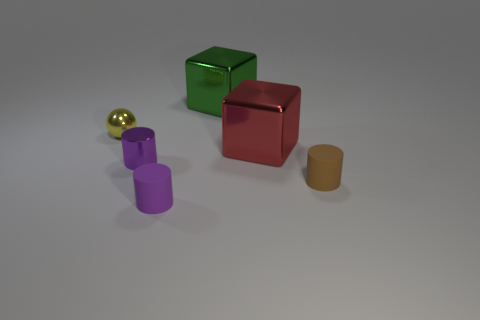How many spheres are either metallic objects or purple metallic objects?
Provide a succinct answer. 1. What is the shape of the shiny object that is in front of the yellow metal object and on the right side of the metallic cylinder?
Ensure brevity in your answer.  Cube. Are there any purple shiny cylinders that have the same size as the green metallic block?
Your answer should be compact. No. How many objects are either objects right of the yellow sphere or large gray matte balls?
Make the answer very short. 5. Are the large red thing and the small purple cylinder behind the purple rubber cylinder made of the same material?
Offer a very short reply. Yes. How many other objects are there of the same shape as the green thing?
Provide a short and direct response. 1. How many things are tiny cylinders that are in front of the tiny brown matte object or small shiny things that are in front of the tiny sphere?
Your answer should be compact. 2. How many other things are the same color as the sphere?
Keep it short and to the point. 0. Are there fewer red things to the left of the large green shiny object than tiny metal objects that are on the right side of the tiny shiny ball?
Offer a very short reply. Yes. How many large gray shiny cylinders are there?
Offer a terse response. 0. 